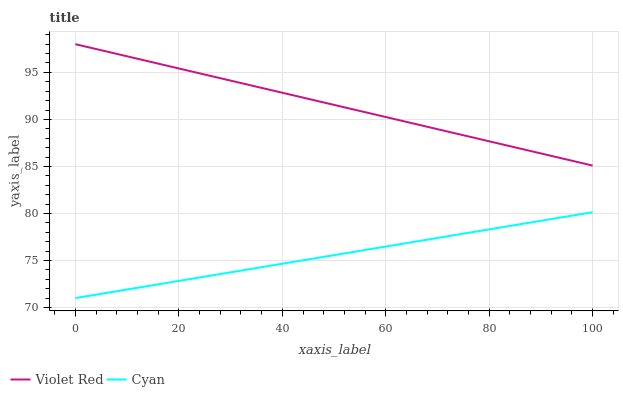Does Cyan have the minimum area under the curve?
Answer yes or no. Yes. Does Violet Red have the maximum area under the curve?
Answer yes or no. Yes. Does Violet Red have the minimum area under the curve?
Answer yes or no. No. Is Violet Red the smoothest?
Answer yes or no. Yes. Is Cyan the roughest?
Answer yes or no. Yes. Is Violet Red the roughest?
Answer yes or no. No. Does Cyan have the lowest value?
Answer yes or no. Yes. Does Violet Red have the lowest value?
Answer yes or no. No. Does Violet Red have the highest value?
Answer yes or no. Yes. Is Cyan less than Violet Red?
Answer yes or no. Yes. Is Violet Red greater than Cyan?
Answer yes or no. Yes. Does Cyan intersect Violet Red?
Answer yes or no. No. 